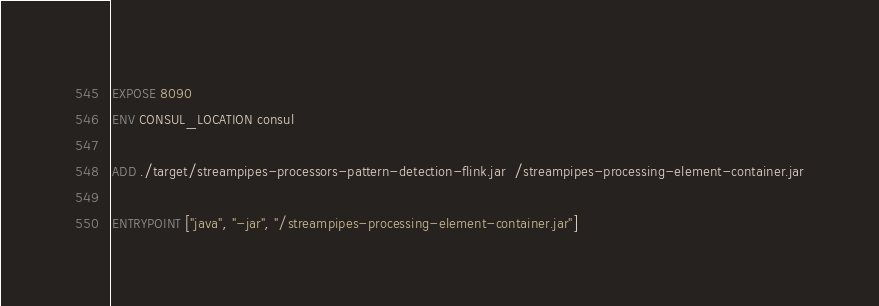<code> <loc_0><loc_0><loc_500><loc_500><_Dockerfile_>
EXPOSE 8090
ENV CONSUL_LOCATION consul

ADD ./target/streampipes-processors-pattern-detection-flink.jar  /streampipes-processing-element-container.jar

ENTRYPOINT ["java", "-jar", "/streampipes-processing-element-container.jar"]
</code> 